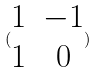<formula> <loc_0><loc_0><loc_500><loc_500>( \begin{matrix} 1 & - 1 \\ 1 & 0 \end{matrix} )</formula> 